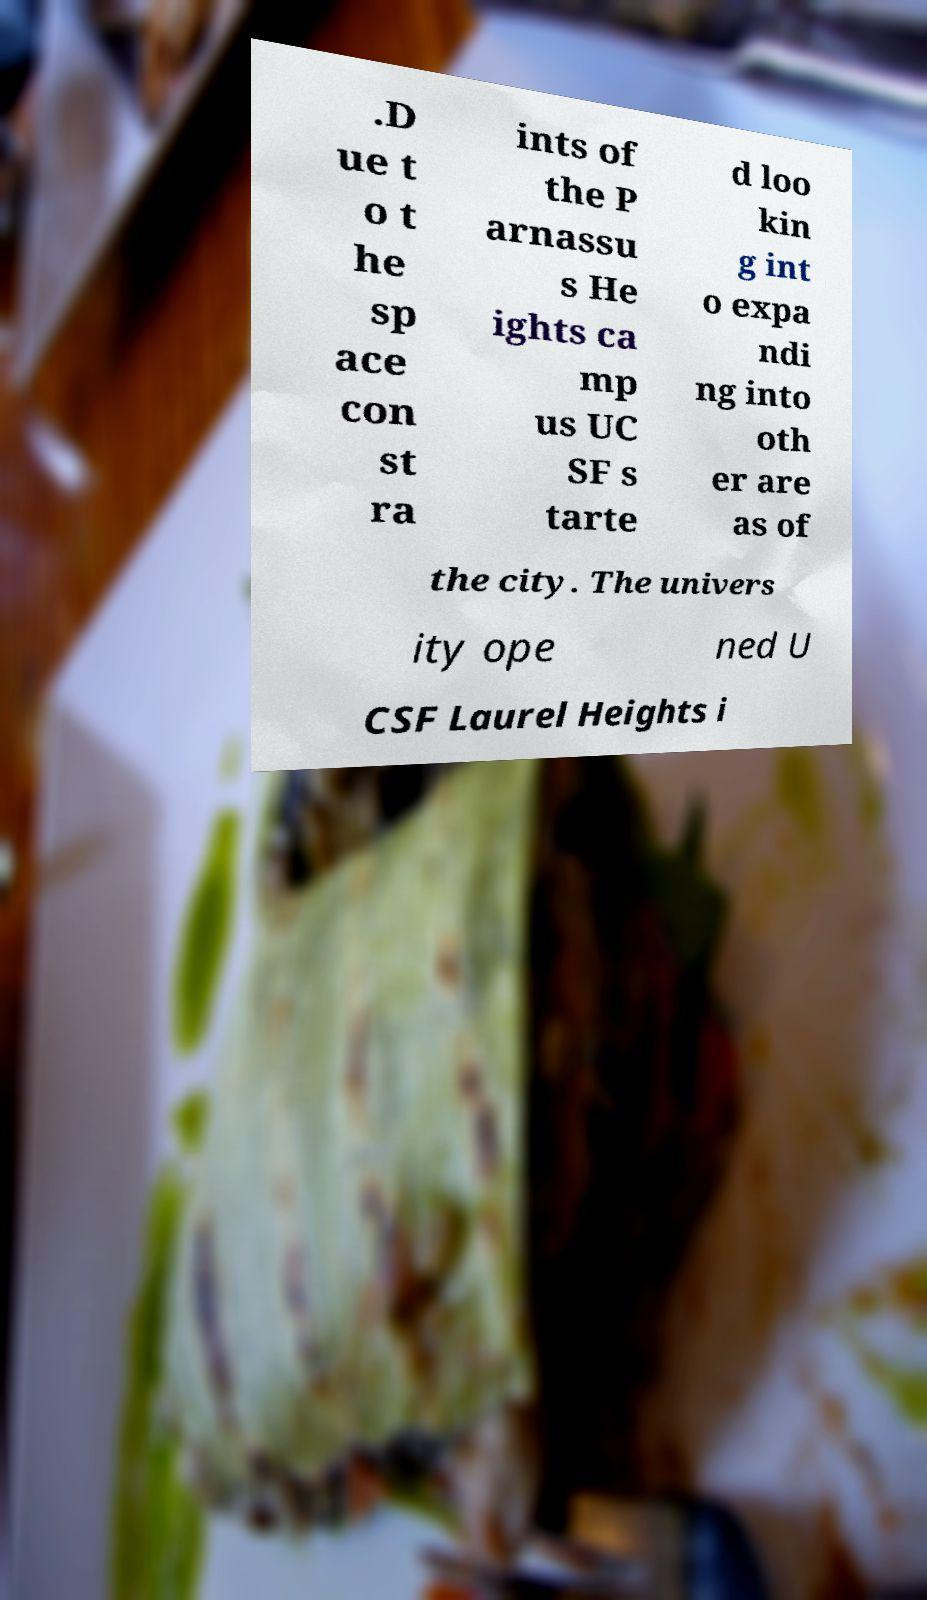I need the written content from this picture converted into text. Can you do that? .D ue t o t he sp ace con st ra ints of the P arnassu s He ights ca mp us UC SF s tarte d loo kin g int o expa ndi ng into oth er are as of the city. The univers ity ope ned U CSF Laurel Heights i 